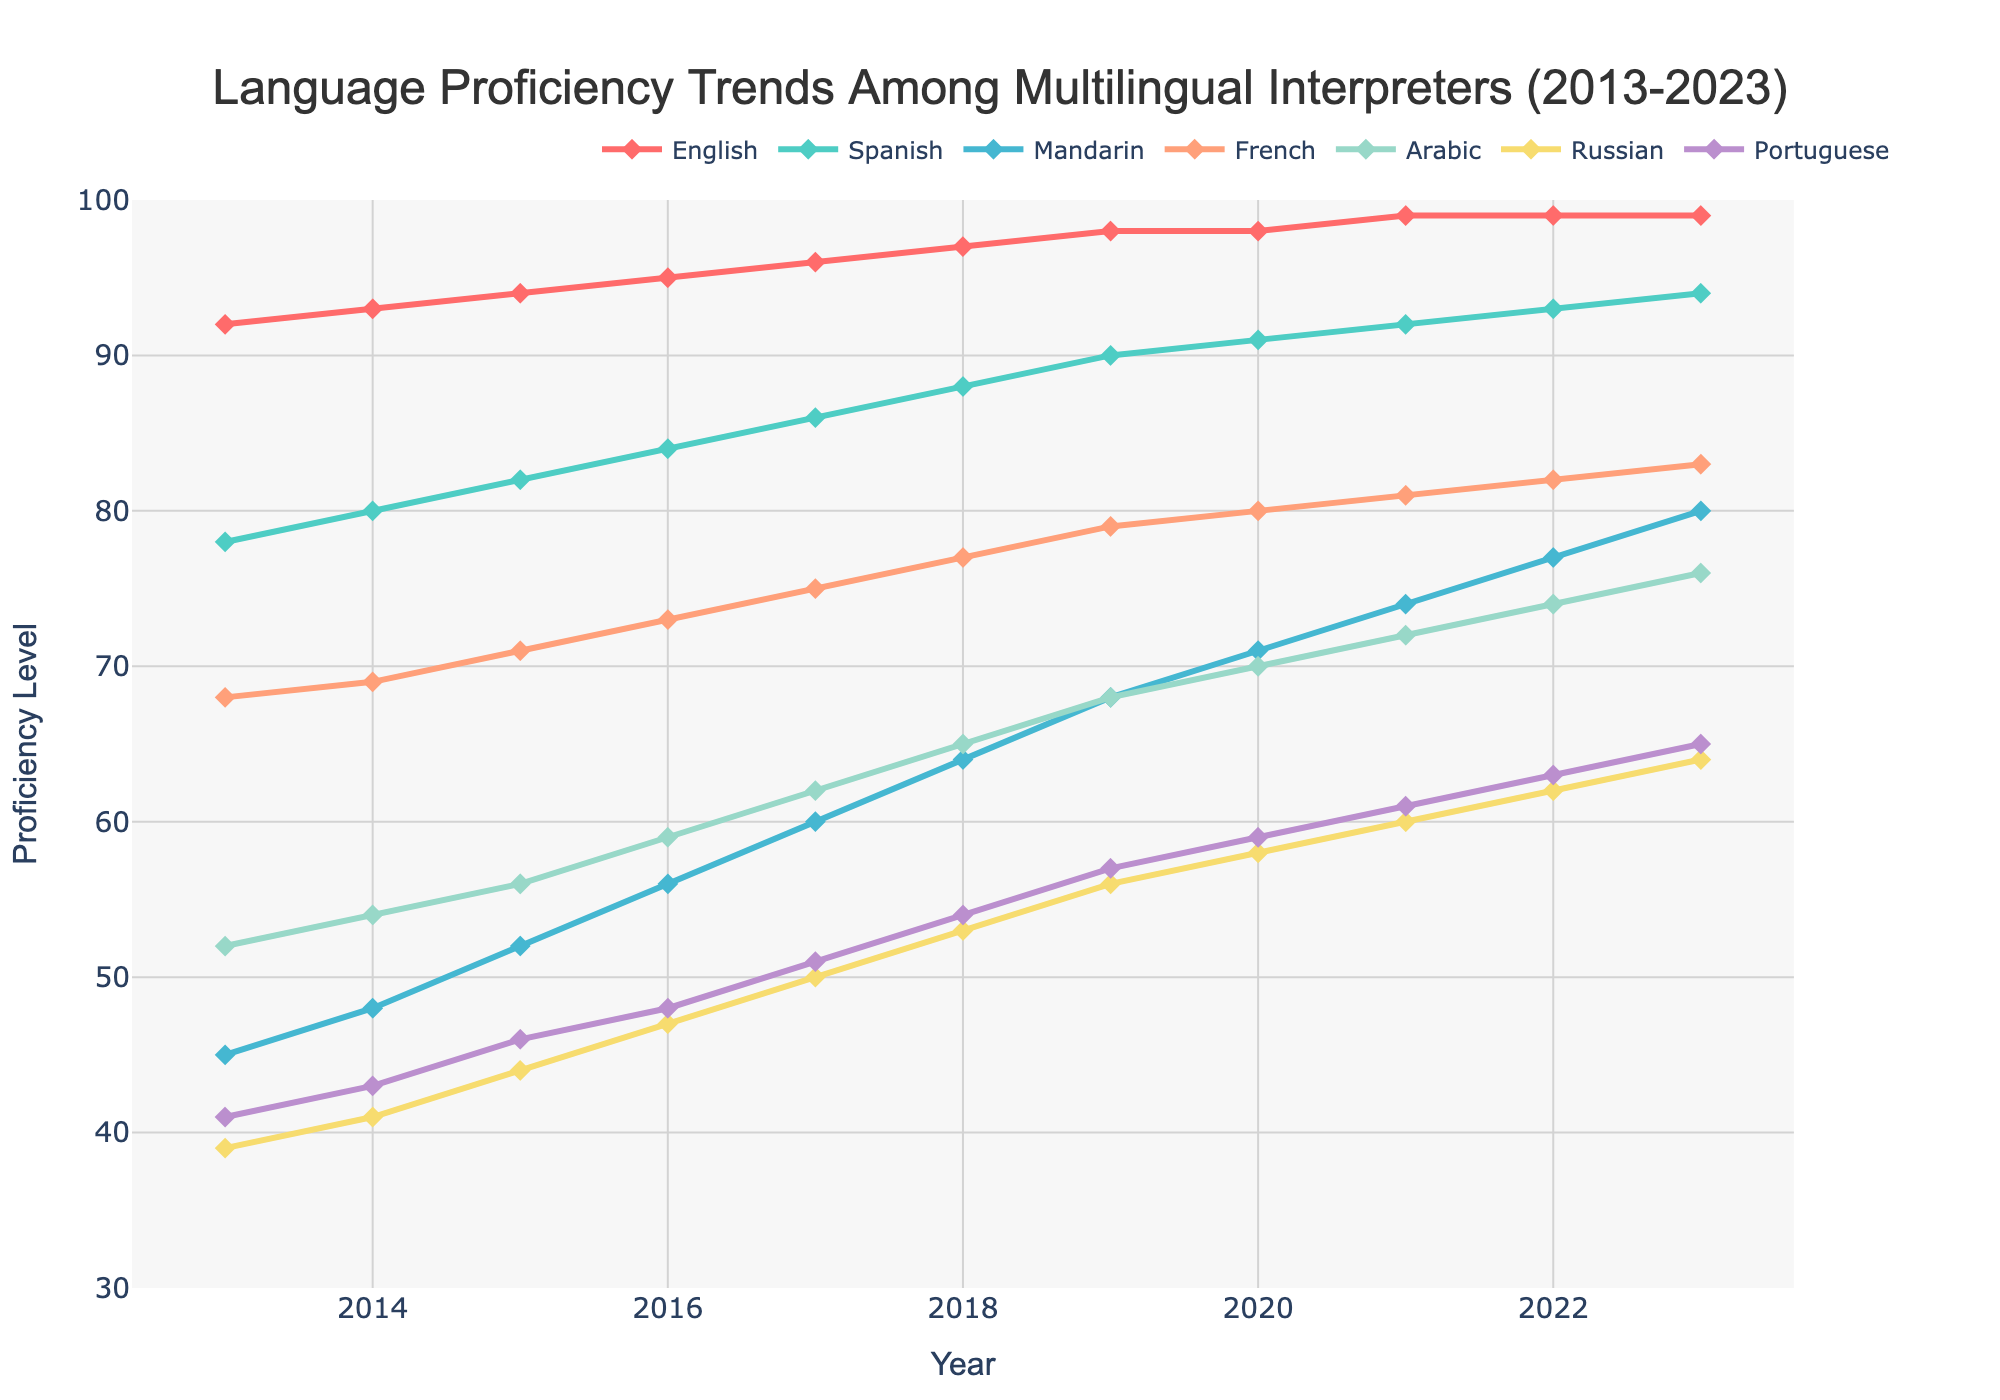What trends can be seen for English proficiency from 2013 to 2023? The proficiency in English consistently increases from 92 in 2013 to 99 in 2020, and it remains steady at 99 from 2020 to 2023.
Answer: Consistent increase and steady at the end Which year shows the highest proficiency level for Mandarin? The highest proficiency level for Mandarin is achieved in the year 2023, where the proficiency value is 80.
Answer: 2023 Compare the proficiency levels of Arabic and French in 2016. Which one was higher? In 2016, the proficiency level for Arabic was 59, while for French it was 73. Hence, French proficiency was higher in that year.
Answer: French What is the average proficiency level of Russian from 2015 to 2020? The proficiency levels for Russian from 2015 to 2020 are 44, 47, 50, 53, 56, and 58. The average is calculated as (44 + 47 + 50 + 53 + 56 + 58) / 6 = 308 / 6 = 51.33.
Answer: 51.33 How much did Portuguese proficiency increase from 2015 to 2023? The proficiency level for Portuguese was 46 in 2015 and increased to 65 in 2023. The increase is calculated as 65 - 46 = 19.
Answer: 19 Which language shows the least proficiency in 2013? In 2013, the language with the least proficiency is Russian, with a value of 39.
Answer: Russian Between which consecutive years did Spanish proficiency increase the most? Between 2013 and 2014, Spanish proficiency increased from 78 to 80, a difference of 2. Comparatively, the increase is less in other years.
Answer: 2013 to 2014 For how many years did Mandarin proficiency stay below 50? Mandarin proficiency was below 50 from 2013 to 2014 (two years) as the proficiency grew beyond 50 from 2015 onwards.
Answer: 2 years What is the color used to represent French proficiency in the chart? The color representing French proficiency in the chart is depicted by the line color that corresponds to French, which is light salmon.
Answer: light salmon By how many points did Spanish proficiency increase from 2018 to 2023? Spanish proficiency was 88 in 2018 and rose to 94 in 2023. The increase is calculated as 94 - 88 = 6.
Answer: 6 